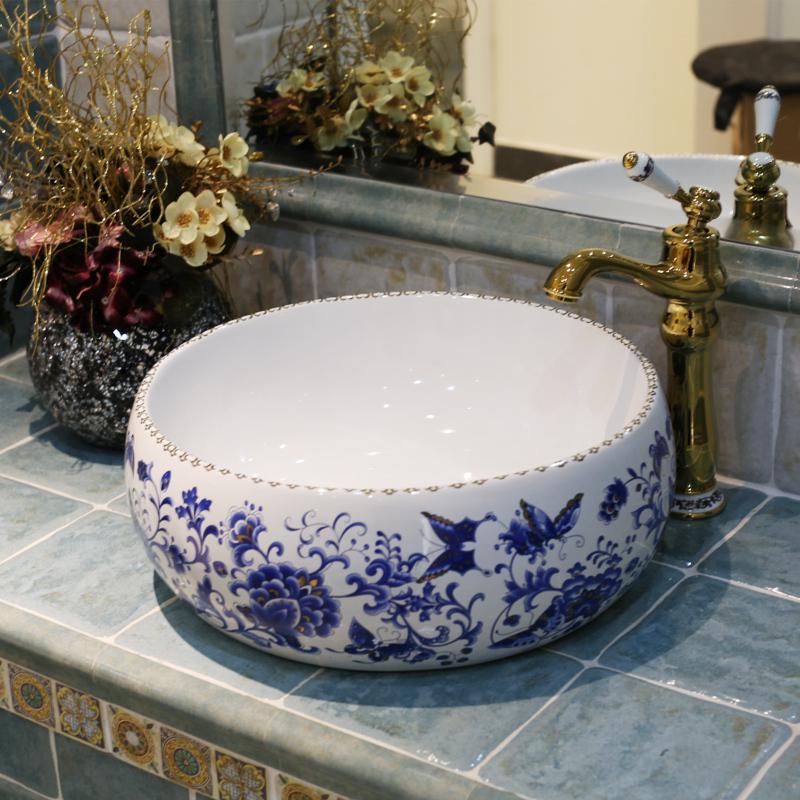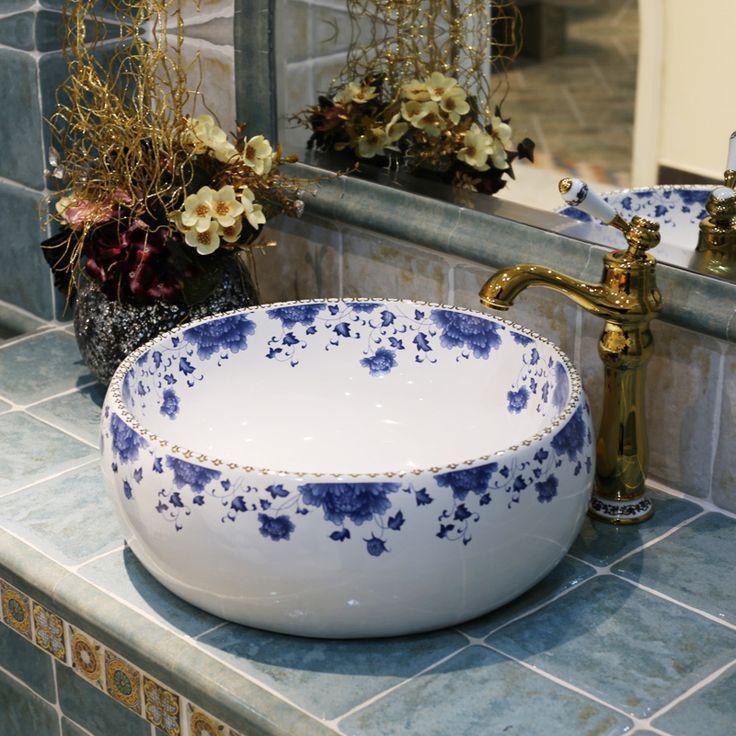The first image is the image on the left, the second image is the image on the right. Assess this claim about the two images: "The sink in the image on the right is set in the counter.". Correct or not? Answer yes or no. No. The first image is the image on the left, the second image is the image on the right. For the images displayed, is the sentence "In one image a round white sink with dark faucets and curved spout is set into a wooden-topped bathroom vanity." factually correct? Answer yes or no. No. 